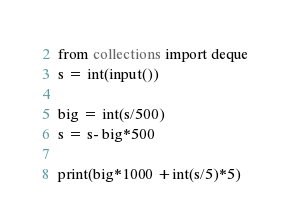Convert code to text. <code><loc_0><loc_0><loc_500><loc_500><_Python_>from collections import deque
s = int(input())

big = int(s/500)
s = s- big*500

print(big*1000 +int(s/5)*5)
</code> 